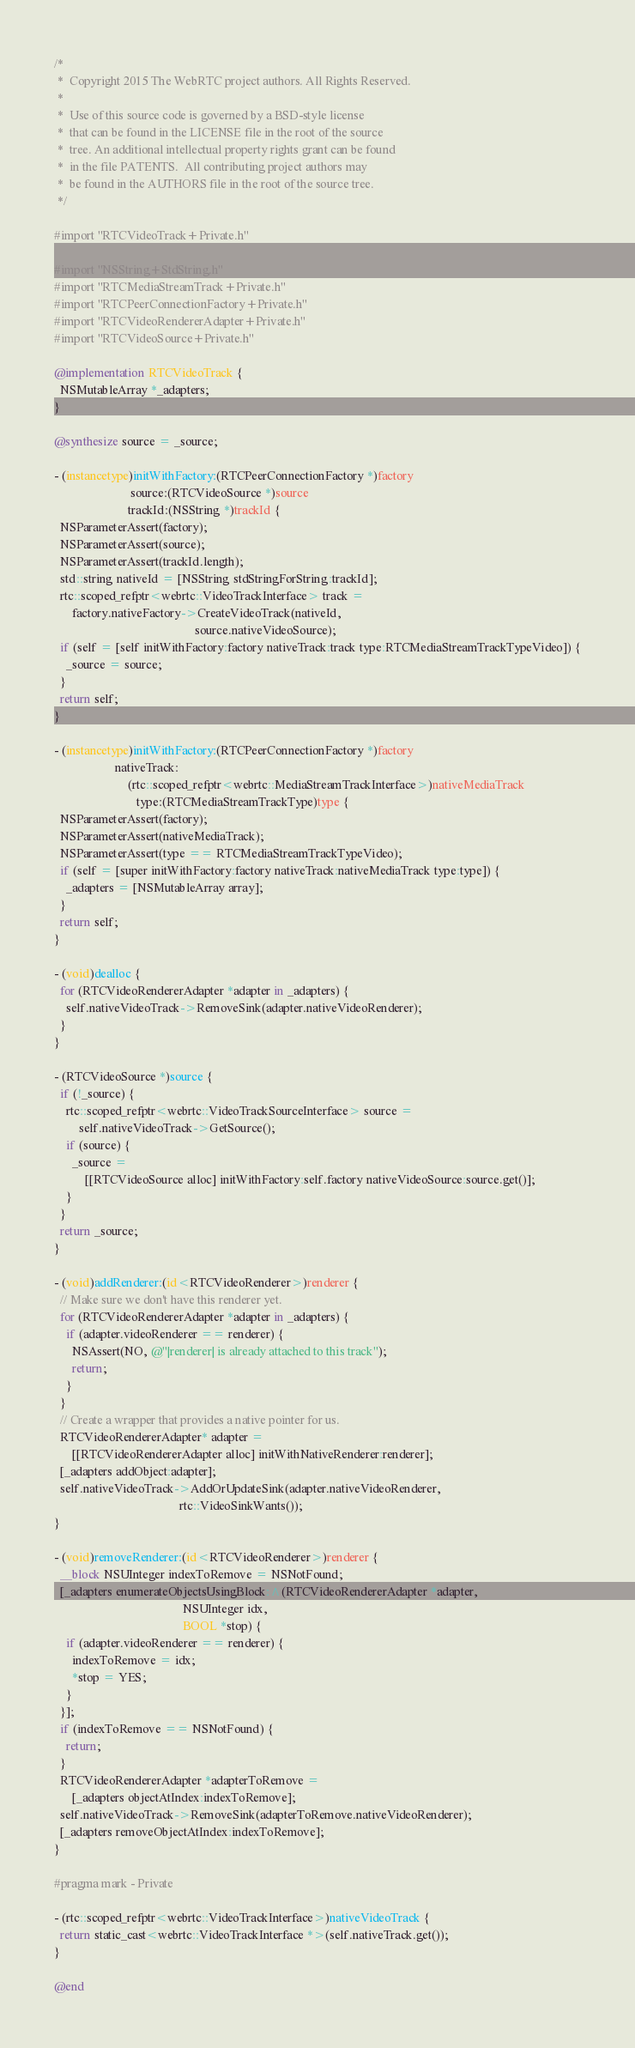<code> <loc_0><loc_0><loc_500><loc_500><_ObjectiveC_>/*
 *  Copyright 2015 The WebRTC project authors. All Rights Reserved.
 *
 *  Use of this source code is governed by a BSD-style license
 *  that can be found in the LICENSE file in the root of the source
 *  tree. An additional intellectual property rights grant can be found
 *  in the file PATENTS.  All contributing project authors may
 *  be found in the AUTHORS file in the root of the source tree.
 */

#import "RTCVideoTrack+Private.h"

#import "NSString+StdString.h"
#import "RTCMediaStreamTrack+Private.h"
#import "RTCPeerConnectionFactory+Private.h"
#import "RTCVideoRendererAdapter+Private.h"
#import "RTCVideoSource+Private.h"

@implementation RTCVideoTrack {
  NSMutableArray *_adapters;
}

@synthesize source = _source;

- (instancetype)initWithFactory:(RTCPeerConnectionFactory *)factory
                         source:(RTCVideoSource *)source
                        trackId:(NSString *)trackId {
  NSParameterAssert(factory);
  NSParameterAssert(source);
  NSParameterAssert(trackId.length);
  std::string nativeId = [NSString stdStringForString:trackId];
  rtc::scoped_refptr<webrtc::VideoTrackInterface> track =
      factory.nativeFactory->CreateVideoTrack(nativeId,
                                              source.nativeVideoSource);
  if (self = [self initWithFactory:factory nativeTrack:track type:RTCMediaStreamTrackTypeVideo]) {
    _source = source;
  }
  return self;
}

- (instancetype)initWithFactory:(RTCPeerConnectionFactory *)factory
                    nativeTrack:
                        (rtc::scoped_refptr<webrtc::MediaStreamTrackInterface>)nativeMediaTrack
                           type:(RTCMediaStreamTrackType)type {
  NSParameterAssert(factory);
  NSParameterAssert(nativeMediaTrack);
  NSParameterAssert(type == RTCMediaStreamTrackTypeVideo);
  if (self = [super initWithFactory:factory nativeTrack:nativeMediaTrack type:type]) {
    _adapters = [NSMutableArray array];
  }
  return self;
}

- (void)dealloc {
  for (RTCVideoRendererAdapter *adapter in _adapters) {
    self.nativeVideoTrack->RemoveSink(adapter.nativeVideoRenderer);
  }
}

- (RTCVideoSource *)source {
  if (!_source) {
    rtc::scoped_refptr<webrtc::VideoTrackSourceInterface> source =
        self.nativeVideoTrack->GetSource();
    if (source) {
      _source =
          [[RTCVideoSource alloc] initWithFactory:self.factory nativeVideoSource:source.get()];
    }
  }
  return _source;
}

- (void)addRenderer:(id<RTCVideoRenderer>)renderer {
  // Make sure we don't have this renderer yet.
  for (RTCVideoRendererAdapter *adapter in _adapters) {
    if (adapter.videoRenderer == renderer) {
      NSAssert(NO, @"|renderer| is already attached to this track");
      return;
    }
  }
  // Create a wrapper that provides a native pointer for us.
  RTCVideoRendererAdapter* adapter =
      [[RTCVideoRendererAdapter alloc] initWithNativeRenderer:renderer];
  [_adapters addObject:adapter];
  self.nativeVideoTrack->AddOrUpdateSink(adapter.nativeVideoRenderer,
                                         rtc::VideoSinkWants());
}

- (void)removeRenderer:(id<RTCVideoRenderer>)renderer {
  __block NSUInteger indexToRemove = NSNotFound;
  [_adapters enumerateObjectsUsingBlock:^(RTCVideoRendererAdapter *adapter,
                                          NSUInteger idx,
                                          BOOL *stop) {
    if (adapter.videoRenderer == renderer) {
      indexToRemove = idx;
      *stop = YES;
    }
  }];
  if (indexToRemove == NSNotFound) {
    return;
  }
  RTCVideoRendererAdapter *adapterToRemove =
      [_adapters objectAtIndex:indexToRemove];
  self.nativeVideoTrack->RemoveSink(adapterToRemove.nativeVideoRenderer);
  [_adapters removeObjectAtIndex:indexToRemove];
}

#pragma mark - Private

- (rtc::scoped_refptr<webrtc::VideoTrackInterface>)nativeVideoTrack {
  return static_cast<webrtc::VideoTrackInterface *>(self.nativeTrack.get());
}

@end
</code> 